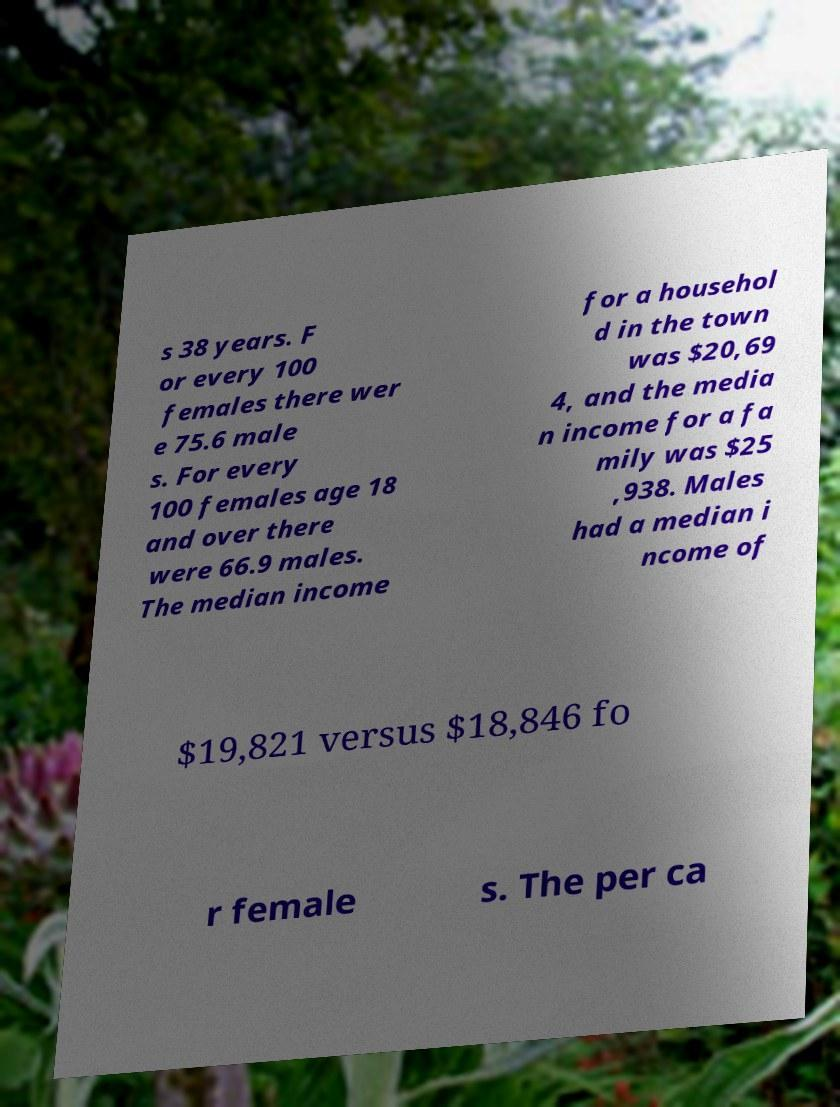There's text embedded in this image that I need extracted. Can you transcribe it verbatim? s 38 years. F or every 100 females there wer e 75.6 male s. For every 100 females age 18 and over there were 66.9 males. The median income for a househol d in the town was $20,69 4, and the media n income for a fa mily was $25 ,938. Males had a median i ncome of $19,821 versus $18,846 fo r female s. The per ca 